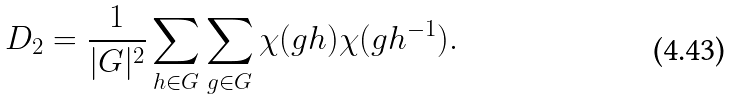<formula> <loc_0><loc_0><loc_500><loc_500>\ D _ { 2 } = \frac { 1 } { | G | ^ { 2 } } \sum _ { h \in G } \sum _ { g \in G } \chi ( g h ) \chi ( g h ^ { - 1 } ) .</formula> 